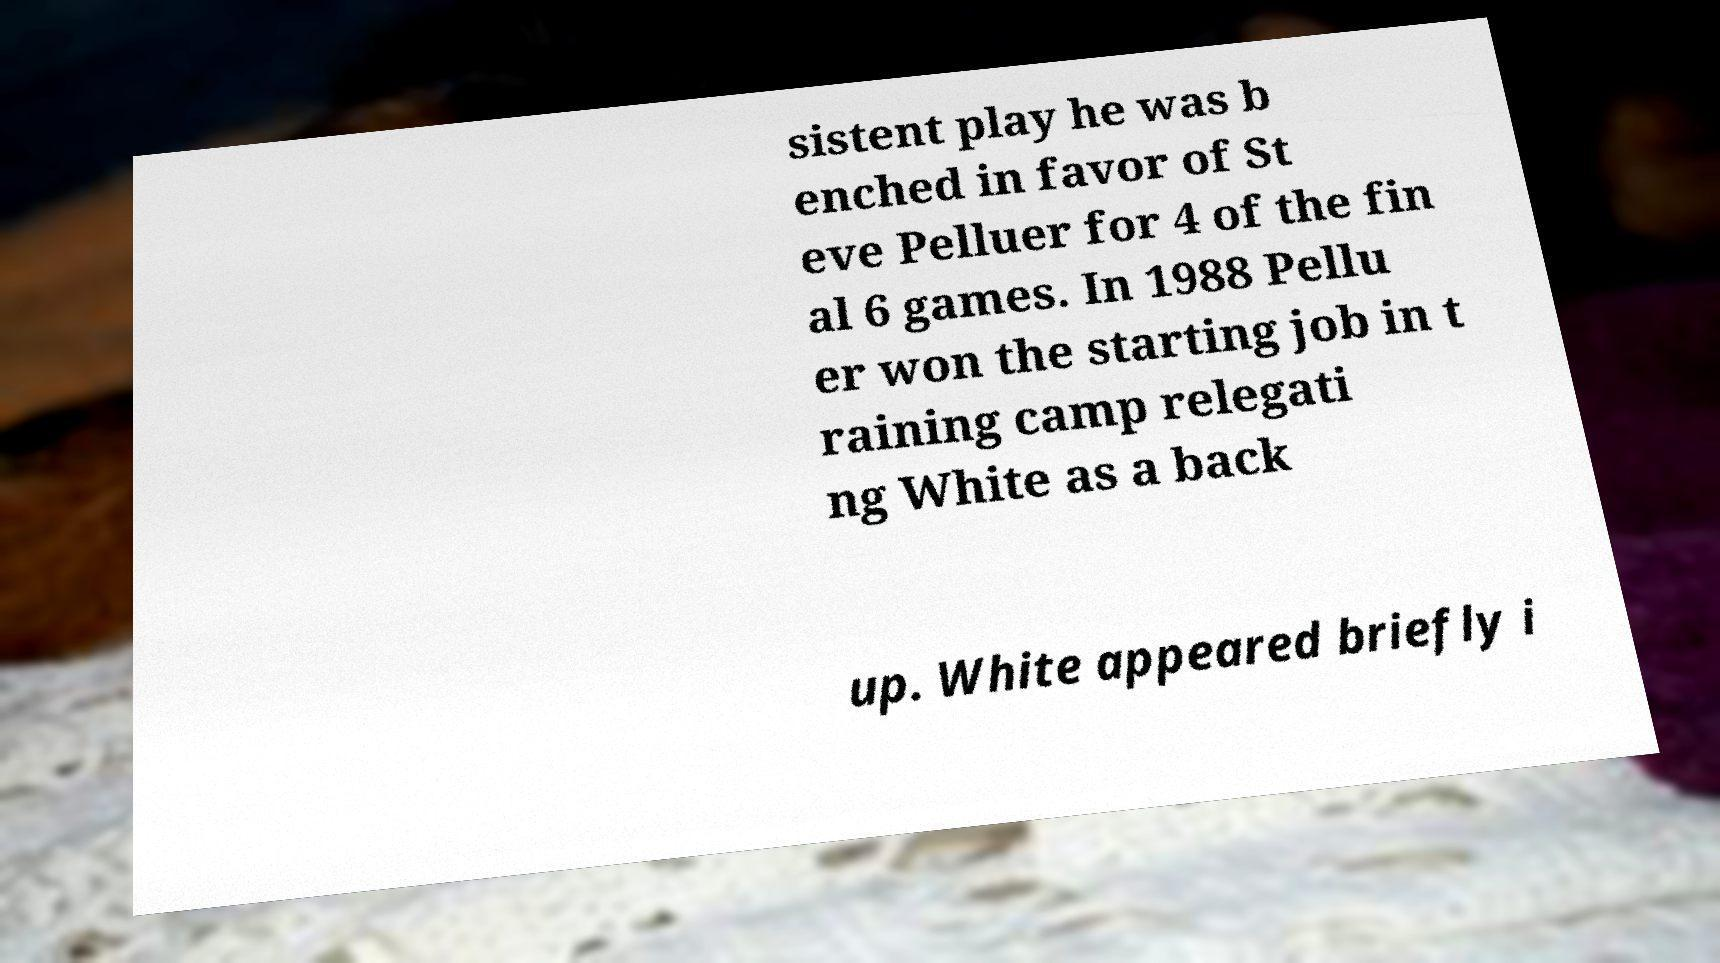There's text embedded in this image that I need extracted. Can you transcribe it verbatim? sistent play he was b enched in favor of St eve Pelluer for 4 of the fin al 6 games. In 1988 Pellu er won the starting job in t raining camp relegati ng White as a back up. White appeared briefly i 